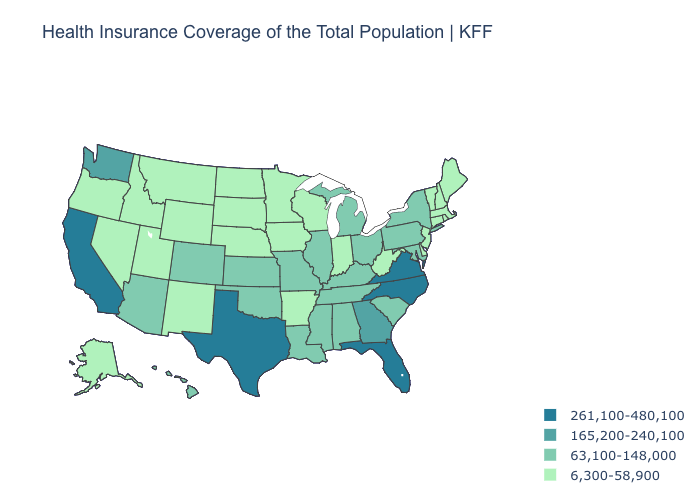Does the first symbol in the legend represent the smallest category?
Quick response, please. No. Among the states that border Massachusetts , which have the lowest value?
Be succinct. Connecticut, New Hampshire, Rhode Island, Vermont. Which states hav the highest value in the Northeast?
Concise answer only. New York, Pennsylvania. What is the lowest value in the South?
Give a very brief answer. 6,300-58,900. Which states have the lowest value in the USA?
Short answer required. Alaska, Arkansas, Connecticut, Delaware, Idaho, Indiana, Iowa, Maine, Massachusetts, Minnesota, Montana, Nebraska, Nevada, New Hampshire, New Jersey, New Mexico, North Dakota, Oregon, Rhode Island, South Dakota, Utah, Vermont, West Virginia, Wisconsin, Wyoming. Among the states that border Ohio , does Michigan have the lowest value?
Answer briefly. No. Does the map have missing data?
Concise answer only. No. Name the states that have a value in the range 6,300-58,900?
Keep it brief. Alaska, Arkansas, Connecticut, Delaware, Idaho, Indiana, Iowa, Maine, Massachusetts, Minnesota, Montana, Nebraska, Nevada, New Hampshire, New Jersey, New Mexico, North Dakota, Oregon, Rhode Island, South Dakota, Utah, Vermont, West Virginia, Wisconsin, Wyoming. Which states hav the highest value in the West?
Write a very short answer. California. Name the states that have a value in the range 261,100-480,100?
Quick response, please. California, Florida, North Carolina, Texas, Virginia. What is the value of Georgia?
Be succinct. 165,200-240,100. What is the value of Montana?
Give a very brief answer. 6,300-58,900. How many symbols are there in the legend?
Concise answer only. 4. What is the value of Arkansas?
Short answer required. 6,300-58,900. Which states have the lowest value in the USA?
Answer briefly. Alaska, Arkansas, Connecticut, Delaware, Idaho, Indiana, Iowa, Maine, Massachusetts, Minnesota, Montana, Nebraska, Nevada, New Hampshire, New Jersey, New Mexico, North Dakota, Oregon, Rhode Island, South Dakota, Utah, Vermont, West Virginia, Wisconsin, Wyoming. 